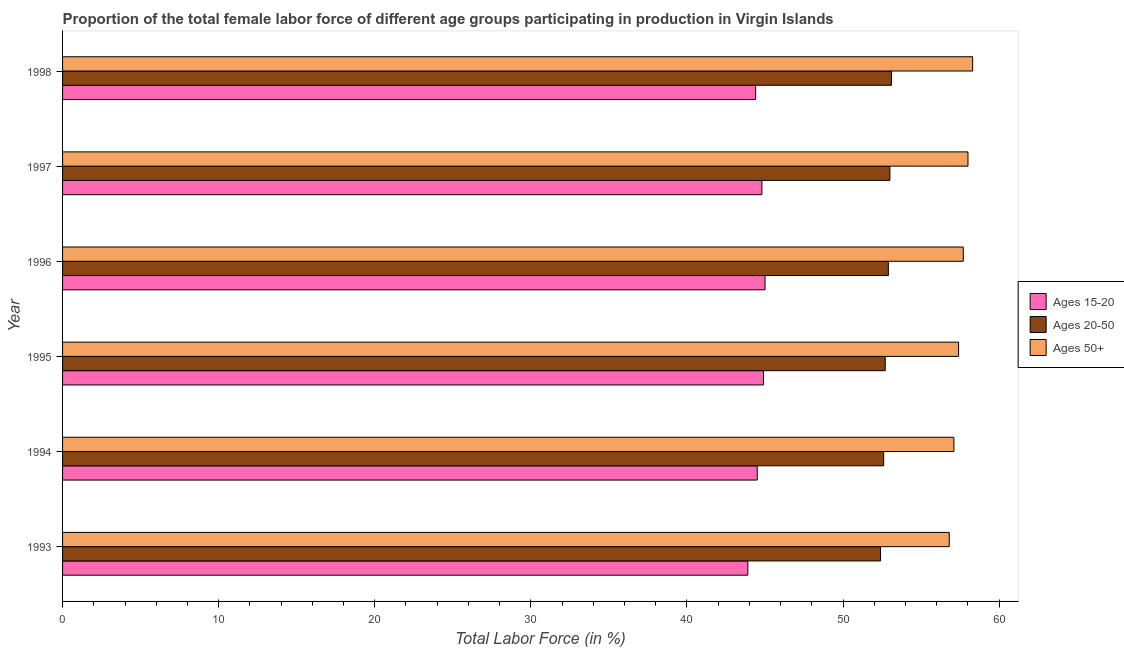How many groups of bars are there?
Your answer should be compact. 6. Are the number of bars per tick equal to the number of legend labels?
Provide a succinct answer. Yes. Are the number of bars on each tick of the Y-axis equal?
Your answer should be very brief. Yes. How many bars are there on the 4th tick from the bottom?
Give a very brief answer. 3. What is the label of the 5th group of bars from the top?
Your response must be concise. 1994. In how many cases, is the number of bars for a given year not equal to the number of legend labels?
Make the answer very short. 0. What is the percentage of female labor force within the age group 15-20 in 1998?
Make the answer very short. 44.4. Across all years, what is the maximum percentage of female labor force above age 50?
Provide a short and direct response. 58.3. Across all years, what is the minimum percentage of female labor force within the age group 15-20?
Provide a succinct answer. 43.9. What is the total percentage of female labor force within the age group 15-20 in the graph?
Your answer should be very brief. 267.5. What is the difference between the percentage of female labor force within the age group 15-20 in 1994 and the percentage of female labor force within the age group 20-50 in 1996?
Provide a short and direct response. -8.4. What is the average percentage of female labor force within the age group 20-50 per year?
Give a very brief answer. 52.78. In how many years, is the percentage of female labor force within the age group 15-20 greater than 6 %?
Offer a very short reply. 6. What is the difference between the highest and the second highest percentage of female labor force within the age group 20-50?
Give a very brief answer. 0.1. What is the difference between the highest and the lowest percentage of female labor force within the age group 20-50?
Offer a terse response. 0.7. Is the sum of the percentage of female labor force above age 50 in 1993 and 1994 greater than the maximum percentage of female labor force within the age group 20-50 across all years?
Make the answer very short. Yes. What does the 3rd bar from the top in 1997 represents?
Offer a terse response. Ages 15-20. What does the 1st bar from the bottom in 1994 represents?
Make the answer very short. Ages 15-20. What is the difference between two consecutive major ticks on the X-axis?
Give a very brief answer. 10. Are the values on the major ticks of X-axis written in scientific E-notation?
Offer a terse response. No. Does the graph contain grids?
Keep it short and to the point. No. Where does the legend appear in the graph?
Your answer should be compact. Center right. What is the title of the graph?
Give a very brief answer. Proportion of the total female labor force of different age groups participating in production in Virgin Islands. Does "Natural gas sources" appear as one of the legend labels in the graph?
Keep it short and to the point. No. What is the label or title of the X-axis?
Ensure brevity in your answer.  Total Labor Force (in %). What is the label or title of the Y-axis?
Provide a succinct answer. Year. What is the Total Labor Force (in %) of Ages 15-20 in 1993?
Your answer should be compact. 43.9. What is the Total Labor Force (in %) of Ages 20-50 in 1993?
Give a very brief answer. 52.4. What is the Total Labor Force (in %) of Ages 50+ in 1993?
Offer a very short reply. 56.8. What is the Total Labor Force (in %) in Ages 15-20 in 1994?
Your answer should be compact. 44.5. What is the Total Labor Force (in %) in Ages 20-50 in 1994?
Provide a short and direct response. 52.6. What is the Total Labor Force (in %) in Ages 50+ in 1994?
Your answer should be very brief. 57.1. What is the Total Labor Force (in %) of Ages 15-20 in 1995?
Ensure brevity in your answer.  44.9. What is the Total Labor Force (in %) of Ages 20-50 in 1995?
Provide a succinct answer. 52.7. What is the Total Labor Force (in %) of Ages 50+ in 1995?
Keep it short and to the point. 57.4. What is the Total Labor Force (in %) in Ages 15-20 in 1996?
Your answer should be compact. 45. What is the Total Labor Force (in %) in Ages 20-50 in 1996?
Your response must be concise. 52.9. What is the Total Labor Force (in %) in Ages 50+ in 1996?
Make the answer very short. 57.7. What is the Total Labor Force (in %) of Ages 15-20 in 1997?
Your response must be concise. 44.8. What is the Total Labor Force (in %) in Ages 20-50 in 1997?
Offer a terse response. 53. What is the Total Labor Force (in %) in Ages 50+ in 1997?
Keep it short and to the point. 58. What is the Total Labor Force (in %) of Ages 15-20 in 1998?
Offer a terse response. 44.4. What is the Total Labor Force (in %) of Ages 20-50 in 1998?
Make the answer very short. 53.1. What is the Total Labor Force (in %) of Ages 50+ in 1998?
Keep it short and to the point. 58.3. Across all years, what is the maximum Total Labor Force (in %) of Ages 15-20?
Make the answer very short. 45. Across all years, what is the maximum Total Labor Force (in %) of Ages 20-50?
Offer a very short reply. 53.1. Across all years, what is the maximum Total Labor Force (in %) in Ages 50+?
Make the answer very short. 58.3. Across all years, what is the minimum Total Labor Force (in %) in Ages 15-20?
Your response must be concise. 43.9. Across all years, what is the minimum Total Labor Force (in %) of Ages 20-50?
Your answer should be very brief. 52.4. Across all years, what is the minimum Total Labor Force (in %) in Ages 50+?
Ensure brevity in your answer.  56.8. What is the total Total Labor Force (in %) of Ages 15-20 in the graph?
Give a very brief answer. 267.5. What is the total Total Labor Force (in %) of Ages 20-50 in the graph?
Your answer should be very brief. 316.7. What is the total Total Labor Force (in %) of Ages 50+ in the graph?
Make the answer very short. 345.3. What is the difference between the Total Labor Force (in %) of Ages 15-20 in 1993 and that in 1994?
Ensure brevity in your answer.  -0.6. What is the difference between the Total Labor Force (in %) of Ages 50+ in 1993 and that in 1994?
Make the answer very short. -0.3. What is the difference between the Total Labor Force (in %) of Ages 20-50 in 1993 and that in 1995?
Provide a succinct answer. -0.3. What is the difference between the Total Labor Force (in %) in Ages 50+ in 1993 and that in 1995?
Your answer should be compact. -0.6. What is the difference between the Total Labor Force (in %) of Ages 15-20 in 1993 and that in 1997?
Offer a very short reply. -0.9. What is the difference between the Total Labor Force (in %) of Ages 15-20 in 1993 and that in 1998?
Your answer should be very brief. -0.5. What is the difference between the Total Labor Force (in %) of Ages 20-50 in 1994 and that in 1996?
Give a very brief answer. -0.3. What is the difference between the Total Labor Force (in %) of Ages 50+ in 1994 and that in 1996?
Offer a terse response. -0.6. What is the difference between the Total Labor Force (in %) in Ages 15-20 in 1994 and that in 1997?
Ensure brevity in your answer.  -0.3. What is the difference between the Total Labor Force (in %) of Ages 20-50 in 1994 and that in 1997?
Provide a short and direct response. -0.4. What is the difference between the Total Labor Force (in %) of Ages 20-50 in 1994 and that in 1998?
Provide a short and direct response. -0.5. What is the difference between the Total Labor Force (in %) in Ages 50+ in 1994 and that in 1998?
Ensure brevity in your answer.  -1.2. What is the difference between the Total Labor Force (in %) of Ages 50+ in 1995 and that in 1996?
Ensure brevity in your answer.  -0.3. What is the difference between the Total Labor Force (in %) of Ages 15-20 in 1995 and that in 1997?
Provide a succinct answer. 0.1. What is the difference between the Total Labor Force (in %) of Ages 15-20 in 1995 and that in 1998?
Offer a terse response. 0.5. What is the difference between the Total Labor Force (in %) in Ages 20-50 in 1995 and that in 1998?
Give a very brief answer. -0.4. What is the difference between the Total Labor Force (in %) in Ages 50+ in 1995 and that in 1998?
Make the answer very short. -0.9. What is the difference between the Total Labor Force (in %) of Ages 20-50 in 1996 and that in 1997?
Your answer should be very brief. -0.1. What is the difference between the Total Labor Force (in %) in Ages 50+ in 1996 and that in 1997?
Provide a succinct answer. -0.3. What is the difference between the Total Labor Force (in %) of Ages 15-20 in 1997 and that in 1998?
Ensure brevity in your answer.  0.4. What is the difference between the Total Labor Force (in %) in Ages 50+ in 1997 and that in 1998?
Your response must be concise. -0.3. What is the difference between the Total Labor Force (in %) of Ages 15-20 in 1993 and the Total Labor Force (in %) of Ages 50+ in 1994?
Your response must be concise. -13.2. What is the difference between the Total Labor Force (in %) in Ages 15-20 in 1993 and the Total Labor Force (in %) in Ages 20-50 in 1995?
Your answer should be compact. -8.8. What is the difference between the Total Labor Force (in %) of Ages 15-20 in 1993 and the Total Labor Force (in %) of Ages 20-50 in 1997?
Ensure brevity in your answer.  -9.1. What is the difference between the Total Labor Force (in %) in Ages 15-20 in 1993 and the Total Labor Force (in %) in Ages 50+ in 1997?
Keep it short and to the point. -14.1. What is the difference between the Total Labor Force (in %) in Ages 20-50 in 1993 and the Total Labor Force (in %) in Ages 50+ in 1997?
Keep it short and to the point. -5.6. What is the difference between the Total Labor Force (in %) in Ages 15-20 in 1993 and the Total Labor Force (in %) in Ages 20-50 in 1998?
Provide a short and direct response. -9.2. What is the difference between the Total Labor Force (in %) in Ages 15-20 in 1993 and the Total Labor Force (in %) in Ages 50+ in 1998?
Your answer should be very brief. -14.4. What is the difference between the Total Labor Force (in %) of Ages 15-20 in 1994 and the Total Labor Force (in %) of Ages 20-50 in 1996?
Provide a succinct answer. -8.4. What is the difference between the Total Labor Force (in %) of Ages 20-50 in 1994 and the Total Labor Force (in %) of Ages 50+ in 1996?
Provide a succinct answer. -5.1. What is the difference between the Total Labor Force (in %) of Ages 15-20 in 1994 and the Total Labor Force (in %) of Ages 50+ in 1997?
Make the answer very short. -13.5. What is the difference between the Total Labor Force (in %) in Ages 15-20 in 1994 and the Total Labor Force (in %) in Ages 50+ in 1998?
Give a very brief answer. -13.8. What is the difference between the Total Labor Force (in %) of Ages 15-20 in 1995 and the Total Labor Force (in %) of Ages 50+ in 1996?
Provide a succinct answer. -12.8. What is the difference between the Total Labor Force (in %) in Ages 20-50 in 1995 and the Total Labor Force (in %) in Ages 50+ in 1996?
Make the answer very short. -5. What is the difference between the Total Labor Force (in %) of Ages 20-50 in 1995 and the Total Labor Force (in %) of Ages 50+ in 1997?
Ensure brevity in your answer.  -5.3. What is the difference between the Total Labor Force (in %) of Ages 15-20 in 1996 and the Total Labor Force (in %) of Ages 50+ in 1997?
Provide a short and direct response. -13. What is the difference between the Total Labor Force (in %) of Ages 20-50 in 1996 and the Total Labor Force (in %) of Ages 50+ in 1997?
Make the answer very short. -5.1. What is the difference between the Total Labor Force (in %) of Ages 15-20 in 1996 and the Total Labor Force (in %) of Ages 20-50 in 1998?
Your response must be concise. -8.1. What is the difference between the Total Labor Force (in %) in Ages 15-20 in 1996 and the Total Labor Force (in %) in Ages 50+ in 1998?
Provide a succinct answer. -13.3. What is the difference between the Total Labor Force (in %) of Ages 15-20 in 1997 and the Total Labor Force (in %) of Ages 50+ in 1998?
Provide a succinct answer. -13.5. What is the average Total Labor Force (in %) of Ages 15-20 per year?
Ensure brevity in your answer.  44.58. What is the average Total Labor Force (in %) in Ages 20-50 per year?
Ensure brevity in your answer.  52.78. What is the average Total Labor Force (in %) in Ages 50+ per year?
Provide a short and direct response. 57.55. In the year 1993, what is the difference between the Total Labor Force (in %) of Ages 15-20 and Total Labor Force (in %) of Ages 20-50?
Offer a very short reply. -8.5. In the year 1994, what is the difference between the Total Labor Force (in %) of Ages 15-20 and Total Labor Force (in %) of Ages 20-50?
Your answer should be very brief. -8.1. In the year 1995, what is the difference between the Total Labor Force (in %) in Ages 15-20 and Total Labor Force (in %) in Ages 20-50?
Keep it short and to the point. -7.8. In the year 1995, what is the difference between the Total Labor Force (in %) of Ages 15-20 and Total Labor Force (in %) of Ages 50+?
Your answer should be very brief. -12.5. In the year 1995, what is the difference between the Total Labor Force (in %) of Ages 20-50 and Total Labor Force (in %) of Ages 50+?
Give a very brief answer. -4.7. In the year 1996, what is the difference between the Total Labor Force (in %) of Ages 15-20 and Total Labor Force (in %) of Ages 20-50?
Offer a very short reply. -7.9. In the year 1996, what is the difference between the Total Labor Force (in %) in Ages 20-50 and Total Labor Force (in %) in Ages 50+?
Provide a succinct answer. -4.8. In the year 1997, what is the difference between the Total Labor Force (in %) of Ages 15-20 and Total Labor Force (in %) of Ages 20-50?
Make the answer very short. -8.2. In the year 1997, what is the difference between the Total Labor Force (in %) in Ages 15-20 and Total Labor Force (in %) in Ages 50+?
Your response must be concise. -13.2. In the year 1998, what is the difference between the Total Labor Force (in %) in Ages 15-20 and Total Labor Force (in %) in Ages 50+?
Your answer should be very brief. -13.9. What is the ratio of the Total Labor Force (in %) in Ages 15-20 in 1993 to that in 1994?
Your answer should be very brief. 0.99. What is the ratio of the Total Labor Force (in %) of Ages 20-50 in 1993 to that in 1994?
Your answer should be compact. 1. What is the ratio of the Total Labor Force (in %) in Ages 50+ in 1993 to that in 1994?
Keep it short and to the point. 0.99. What is the ratio of the Total Labor Force (in %) in Ages 15-20 in 1993 to that in 1995?
Your answer should be compact. 0.98. What is the ratio of the Total Labor Force (in %) of Ages 20-50 in 1993 to that in 1995?
Offer a terse response. 0.99. What is the ratio of the Total Labor Force (in %) of Ages 50+ in 1993 to that in 1995?
Give a very brief answer. 0.99. What is the ratio of the Total Labor Force (in %) in Ages 15-20 in 1993 to that in 1996?
Your answer should be compact. 0.98. What is the ratio of the Total Labor Force (in %) of Ages 20-50 in 1993 to that in 1996?
Your answer should be compact. 0.99. What is the ratio of the Total Labor Force (in %) in Ages 50+ in 1993 to that in 1996?
Make the answer very short. 0.98. What is the ratio of the Total Labor Force (in %) in Ages 15-20 in 1993 to that in 1997?
Ensure brevity in your answer.  0.98. What is the ratio of the Total Labor Force (in %) of Ages 20-50 in 1993 to that in 1997?
Your response must be concise. 0.99. What is the ratio of the Total Labor Force (in %) in Ages 50+ in 1993 to that in 1997?
Offer a very short reply. 0.98. What is the ratio of the Total Labor Force (in %) in Ages 15-20 in 1993 to that in 1998?
Your answer should be compact. 0.99. What is the ratio of the Total Labor Force (in %) of Ages 20-50 in 1993 to that in 1998?
Provide a succinct answer. 0.99. What is the ratio of the Total Labor Force (in %) in Ages 50+ in 1993 to that in 1998?
Your answer should be compact. 0.97. What is the ratio of the Total Labor Force (in %) of Ages 20-50 in 1994 to that in 1995?
Ensure brevity in your answer.  1. What is the ratio of the Total Labor Force (in %) of Ages 50+ in 1994 to that in 1995?
Your answer should be compact. 0.99. What is the ratio of the Total Labor Force (in %) of Ages 15-20 in 1994 to that in 1996?
Give a very brief answer. 0.99. What is the ratio of the Total Labor Force (in %) in Ages 20-50 in 1994 to that in 1996?
Keep it short and to the point. 0.99. What is the ratio of the Total Labor Force (in %) in Ages 50+ in 1994 to that in 1996?
Provide a short and direct response. 0.99. What is the ratio of the Total Labor Force (in %) of Ages 20-50 in 1994 to that in 1997?
Your response must be concise. 0.99. What is the ratio of the Total Labor Force (in %) of Ages 50+ in 1994 to that in 1997?
Offer a terse response. 0.98. What is the ratio of the Total Labor Force (in %) of Ages 15-20 in 1994 to that in 1998?
Your answer should be very brief. 1. What is the ratio of the Total Labor Force (in %) of Ages 20-50 in 1994 to that in 1998?
Offer a terse response. 0.99. What is the ratio of the Total Labor Force (in %) of Ages 50+ in 1994 to that in 1998?
Your response must be concise. 0.98. What is the ratio of the Total Labor Force (in %) in Ages 15-20 in 1995 to that in 1996?
Offer a very short reply. 1. What is the ratio of the Total Labor Force (in %) of Ages 50+ in 1995 to that in 1996?
Make the answer very short. 0.99. What is the ratio of the Total Labor Force (in %) of Ages 20-50 in 1995 to that in 1997?
Give a very brief answer. 0.99. What is the ratio of the Total Labor Force (in %) of Ages 50+ in 1995 to that in 1997?
Make the answer very short. 0.99. What is the ratio of the Total Labor Force (in %) of Ages 15-20 in 1995 to that in 1998?
Offer a very short reply. 1.01. What is the ratio of the Total Labor Force (in %) of Ages 50+ in 1995 to that in 1998?
Give a very brief answer. 0.98. What is the ratio of the Total Labor Force (in %) of Ages 15-20 in 1996 to that in 1997?
Offer a very short reply. 1. What is the ratio of the Total Labor Force (in %) in Ages 20-50 in 1996 to that in 1997?
Provide a short and direct response. 1. What is the ratio of the Total Labor Force (in %) in Ages 15-20 in 1996 to that in 1998?
Ensure brevity in your answer.  1.01. What is the ratio of the Total Labor Force (in %) of Ages 15-20 in 1997 to that in 1998?
Provide a succinct answer. 1.01. What is the difference between the highest and the second highest Total Labor Force (in %) in Ages 15-20?
Offer a terse response. 0.1. What is the difference between the highest and the second highest Total Labor Force (in %) of Ages 50+?
Provide a succinct answer. 0.3. What is the difference between the highest and the lowest Total Labor Force (in %) of Ages 15-20?
Give a very brief answer. 1.1. What is the difference between the highest and the lowest Total Labor Force (in %) of Ages 20-50?
Your response must be concise. 0.7. 